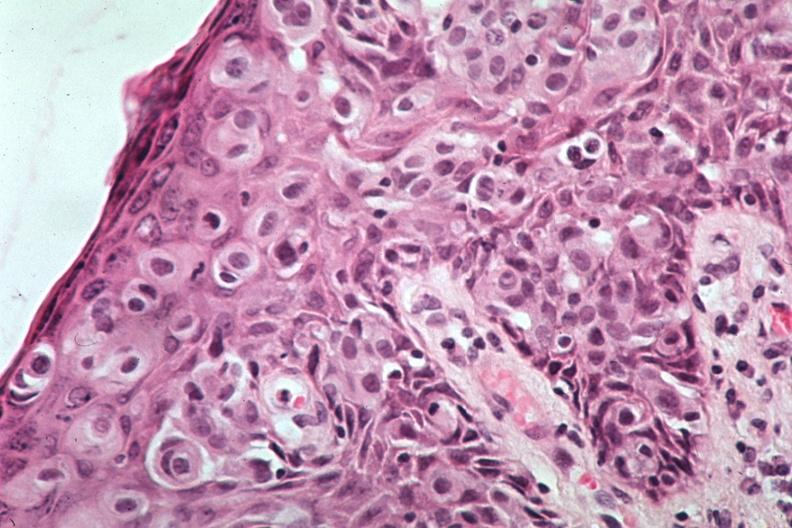what is present?
Answer the question using a single word or phrase. Breast 